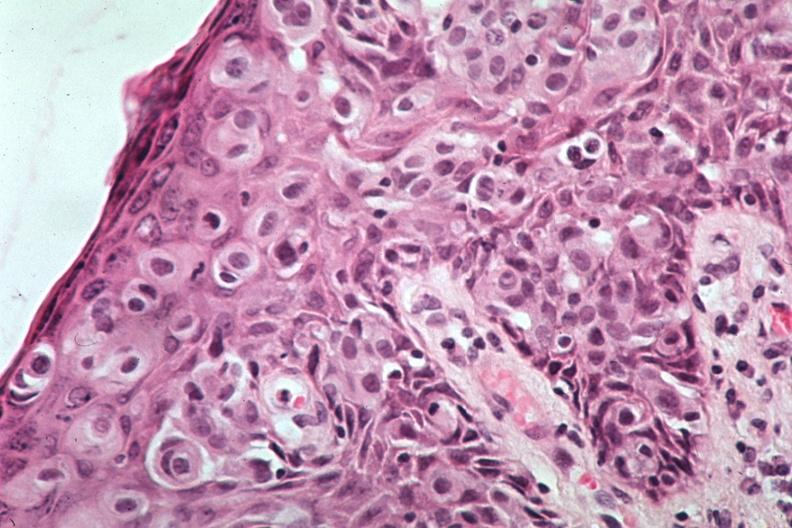what is present?
Answer the question using a single word or phrase. Breast 